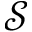<formula> <loc_0><loc_0><loc_500><loc_500>\mathcal { S }</formula> 